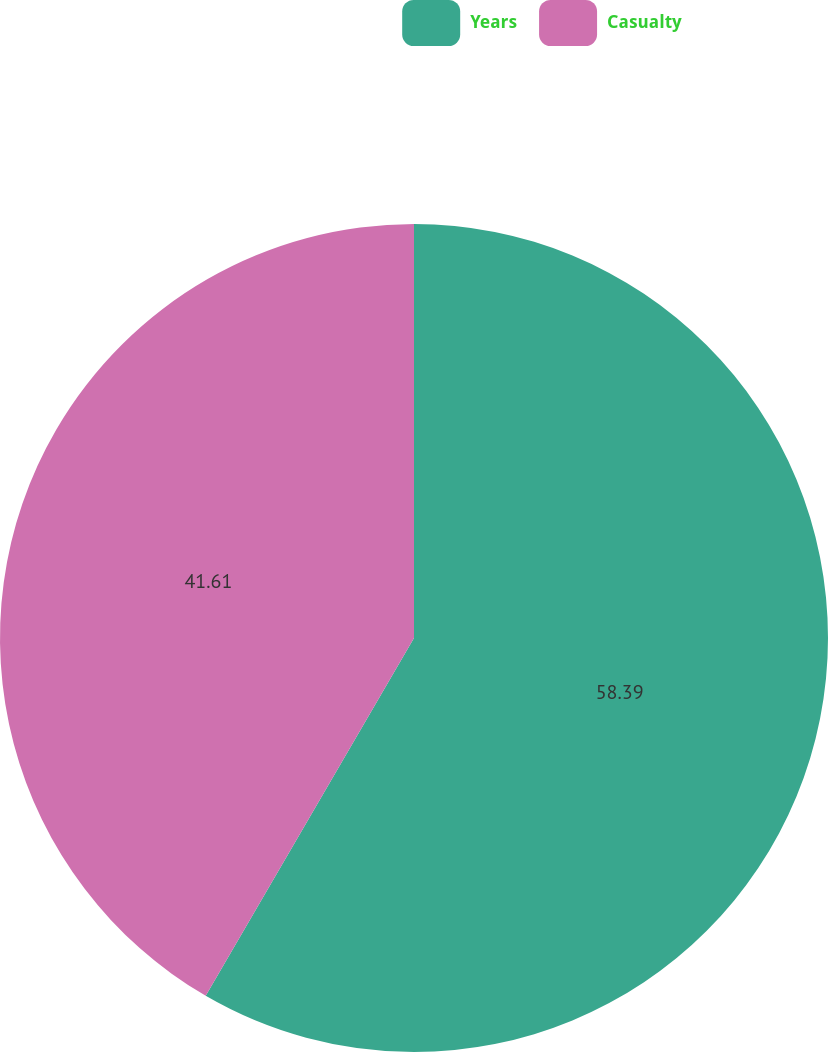<chart> <loc_0><loc_0><loc_500><loc_500><pie_chart><fcel>Years<fcel>Casualty<nl><fcel>58.39%<fcel>41.61%<nl></chart> 